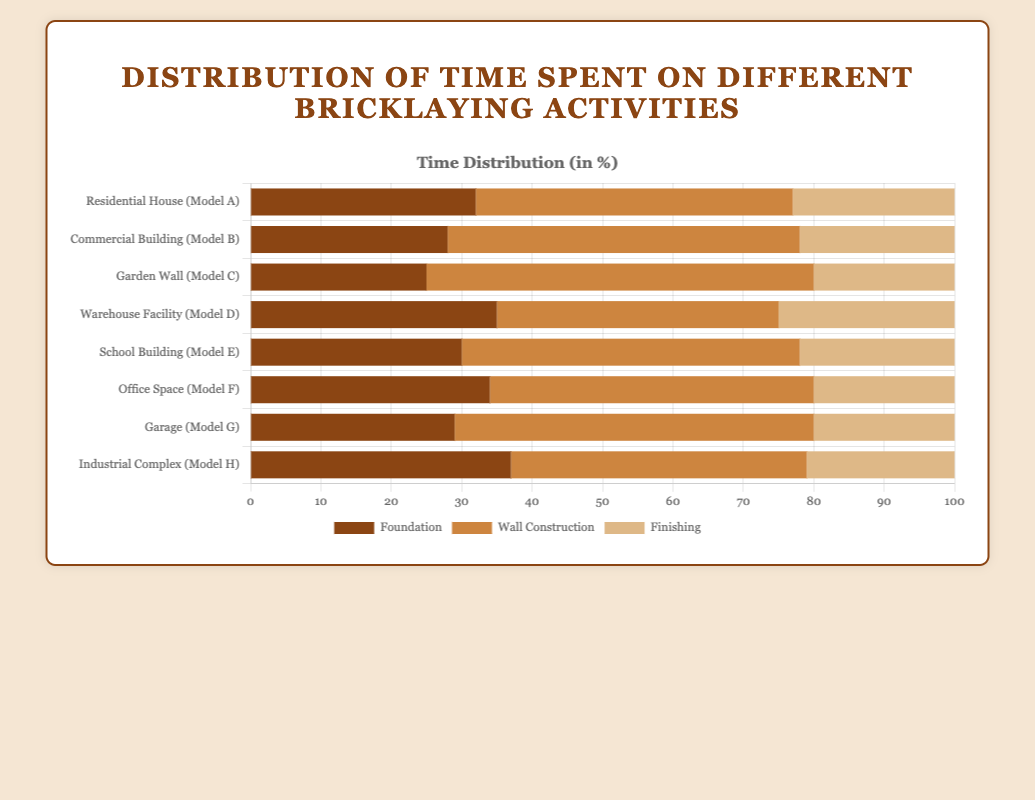Which project has the highest percentage of time spent on wall construction? The project "Garden Wall (Model C)" has the highest percentage of time spent on wall construction with 55%. This can be identified by comparing the lengths of the wall construction bars for all projects, with Model C's bar being the longest.
Answer: Garden Wall (Model C) What is the total percentage of time spent on foundation and finishing for the "Warehouse Facility (Model D)" project? For the "Warehouse Facility (Model D)" project, the time spent on foundation is 35% and on finishing is 25%. Adding these two values together gives 35 + 25 = 60%.
Answer: 60% Which project has the least time spent on foundation? The project "Garden Wall (Model C)" has the least time spent on foundation with 25%. This is evident from the foundation bars across all projects, with Model C having the shortest bar for foundation.
Answer: Garden Wall (Model C) Compare wall construction times: Which project has a greater percentage spent on wall construction, "Residential House (Model A)" or "Office Space (Model F)"? The "Residential House (Model A)" spends 45% of time on wall construction, while "Office Space (Model F)" spends 46%. Thus, "Office Space (Model F)" has a greater percentage spent on wall construction.
Answer: Office Space (Model F) What is the average percentage of time spent on finishing for all projects? The percentages of time spent on finishing are: 23, 22, 20, 25, 22, 20, 20, 21. Adding these gives 173. Dividing by 8 projects, the average is 173 / 8 = 21.625%.
Answer: 21.625% How many projects have a finishing time greater than 22%? By examining the finishing percentages for all projects (23, 22, 20, 25, 22, 20, 20, 21), only 2 projects have a finishing time greater than 22% (23 and 25).
Answer: 2 Is the percentage of time spent on foundation for "Industrial Complex (Model H)" greater than for "Office Space (Model F)"? "Industrial Complex (Model H)" has 37% time spent on foundation, while "Office Space (Model F)" has 34%. Therefore, the percentage for "Industrial Complex (Model H)" is greater.
Answer: Yes 